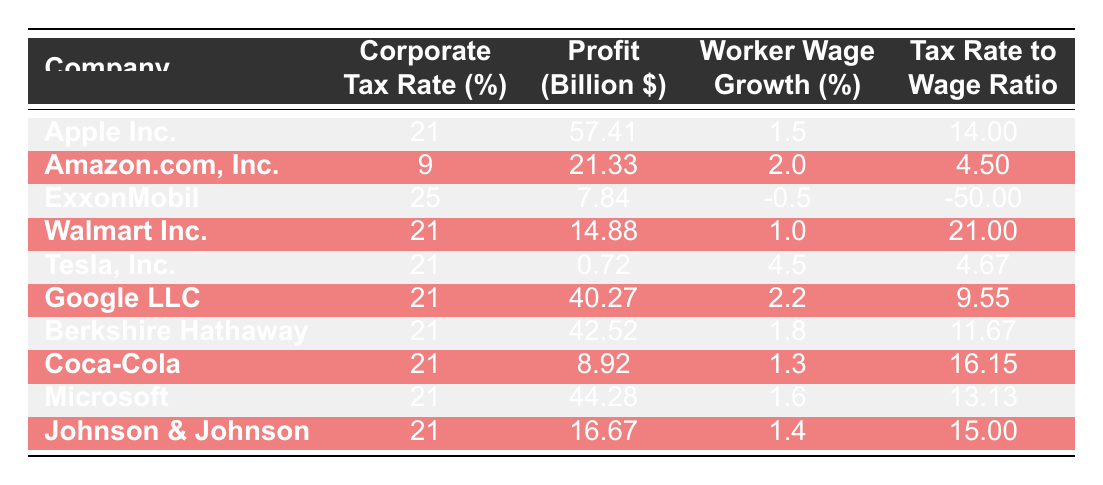What is the corporate tax rate for Amazon.com, Inc.? The table shows that the corporate tax rate for Amazon.com, Inc. is listed in the Corporate Tax Rate column next to the company name. It reads 9%.
Answer: 9% Which company had the highest profit in 2020? To find the company with the highest profit, we look at the Profit Billion column. The highest value is 57.41, next to Apple Inc.
Answer: Apple Inc What is the average worker wage growth for companies with a corporate tax rate of 21%? Identify companies with a corporate tax rate of 21%: Apple Inc., Walmart Inc., Tesla, Inc., Google LLC, Berkshire Hathaway, Coca-Cola, Microsoft, and Johnson & Johnson. Their worker wage growth values are: 1.5, 1.0, 4.5, 2.2, 1.8, 1.3, 1.6, and 1.4. The sum of these values is 14.3, and there are 8 companies, so the average is 14.3 / 8 = 1.7875.
Answer: 1.79 Is it true that all companies listed had positive worker wage growth? We can check the Worker Wage Growth Percent column for each company. ExxonMobil shows a value of -0.5, which is negative. Therefore, not all companies had positive wage growth.
Answer: No Which company exhibited the lowest worker wage growth and what was that percentage? The table shows the Worker Wage Growth Percent column values, and ExxonMobil has the lowest at -0.5%.
Answer: -0.5% What is the profit to wage growth ratio for Tesla, Inc.? First, we find Tesla, Inc. in the table. The profit is 0.72 billion, and the worker wage growth is 4.5%. To find the profit to wage growth ratio, we divide profit by the wage growth: 0.72 / 4.5 = 0.16.
Answer: 0.16 How many companies had a corporate tax rate lower than 21%? By reviewing the Corporate Tax Rate column, we find that only Amazon.com, Inc. has a tax rate lower than 21%, which is 9%. So the total count is 1 company.
Answer: 1 Which companies had both significant profits (over 20 billion) and a corporate tax rate of 21%? Checking the Corporate Tax Rate and Profit Billion columns, companies with more than 20 billion profits and a 21% tax rate are Apple Inc. (57.41), Google LLC (40.27), and Berkshire Hathaway (42.52).
Answer: Apple Inc., Google LLC, Berkshire Hathaway 